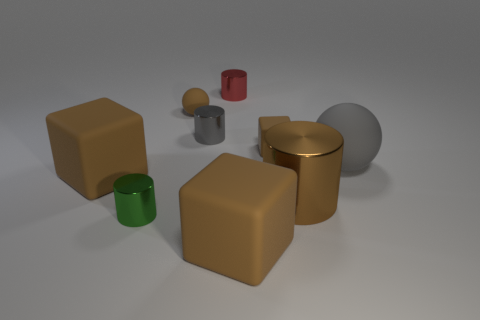Subtract 1 cylinders. How many cylinders are left? 3 Subtract all purple cylinders. Subtract all purple spheres. How many cylinders are left? 4 Subtract all cylinders. How many objects are left? 5 Subtract all small brown rubber blocks. Subtract all blocks. How many objects are left? 5 Add 2 small gray metal cylinders. How many small gray metal cylinders are left? 3 Add 7 gray spheres. How many gray spheres exist? 8 Subtract 0 green cubes. How many objects are left? 9 